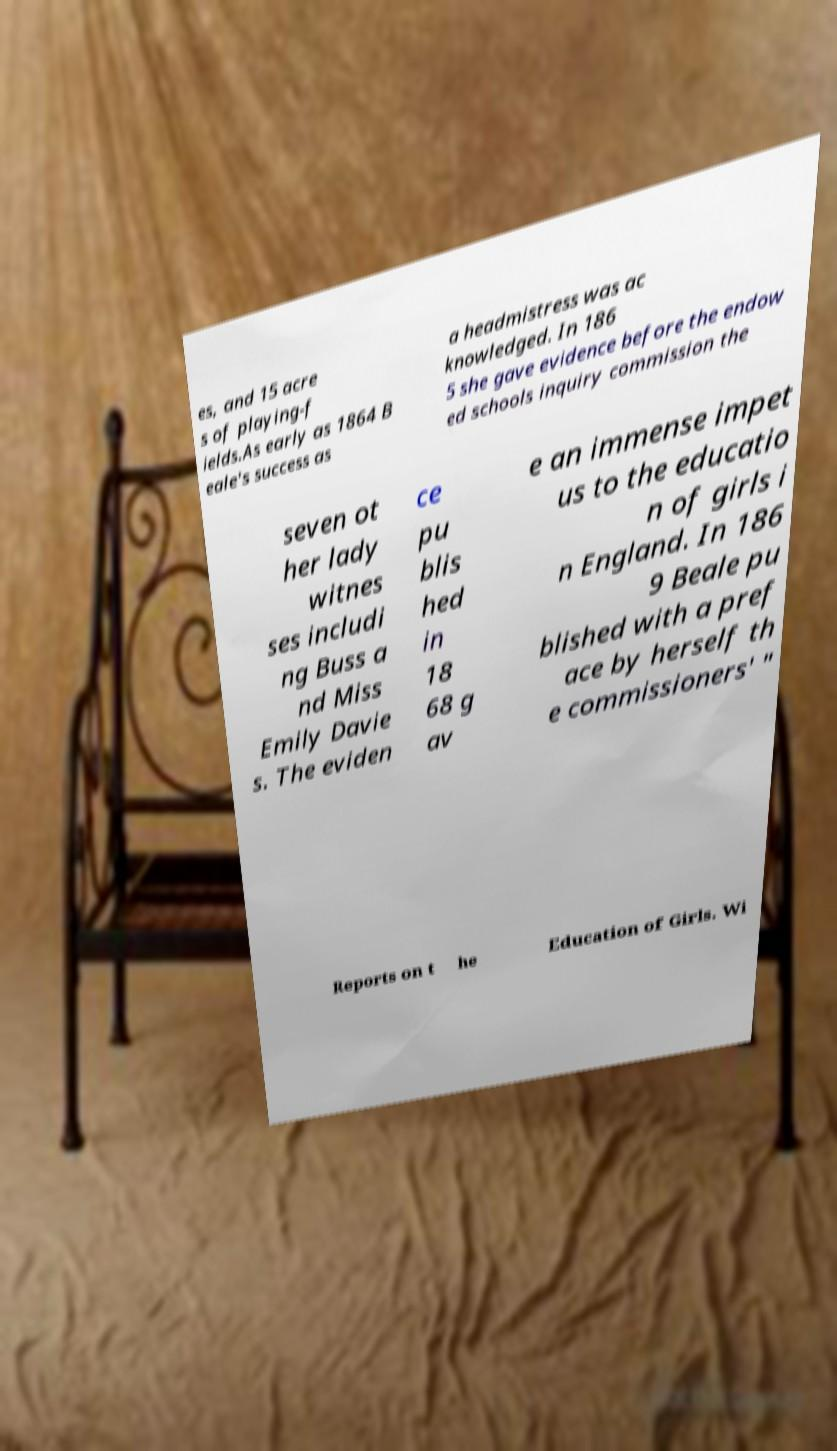Can you read and provide the text displayed in the image?This photo seems to have some interesting text. Can you extract and type it out for me? es, and 15 acre s of playing-f ields.As early as 1864 B eale's success as a headmistress was ac knowledged. In 186 5 she gave evidence before the endow ed schools inquiry commission the seven ot her lady witnes ses includi ng Buss a nd Miss Emily Davie s. The eviden ce pu blis hed in 18 68 g av e an immense impet us to the educatio n of girls i n England. In 186 9 Beale pu blished with a pref ace by herself th e commissioners' " Reports on t he Education of Girls. Wi 